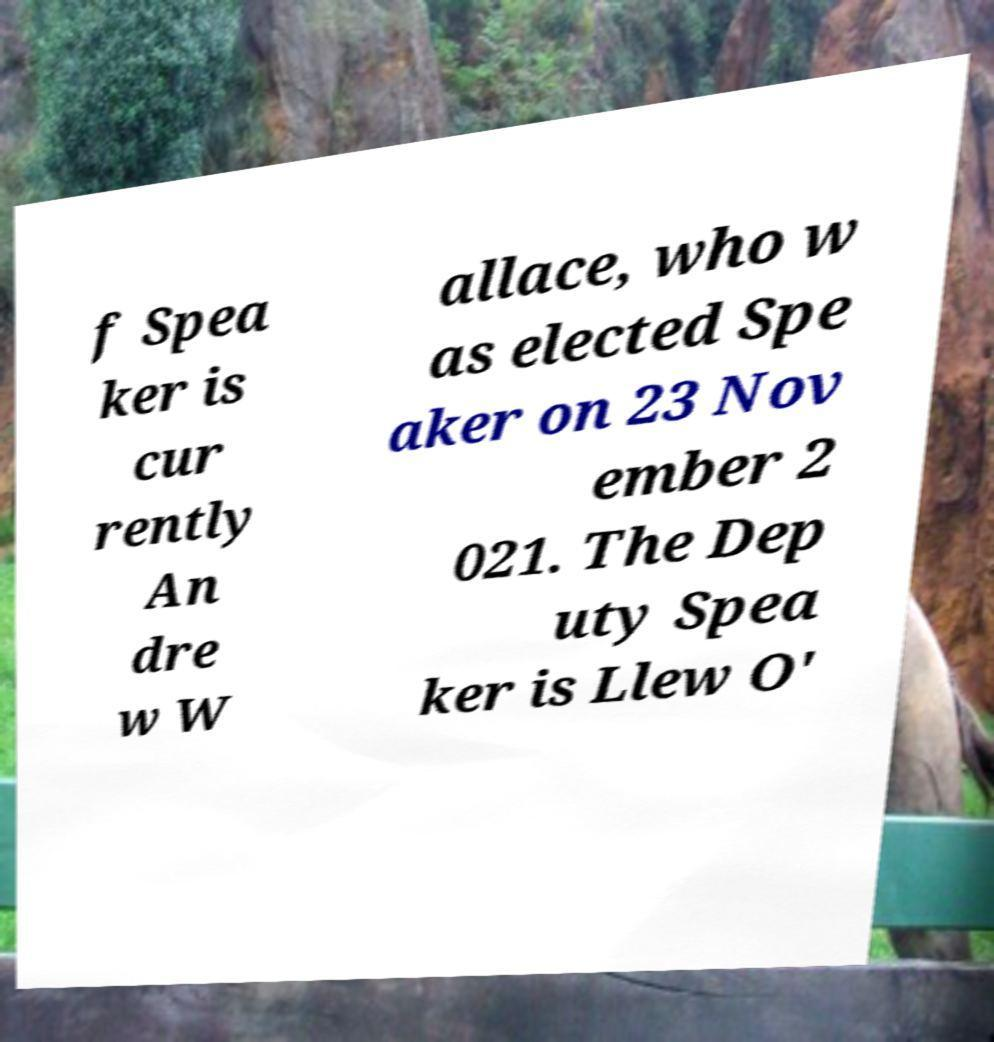For documentation purposes, I need the text within this image transcribed. Could you provide that? f Spea ker is cur rently An dre w W allace, who w as elected Spe aker on 23 Nov ember 2 021. The Dep uty Spea ker is Llew O' 